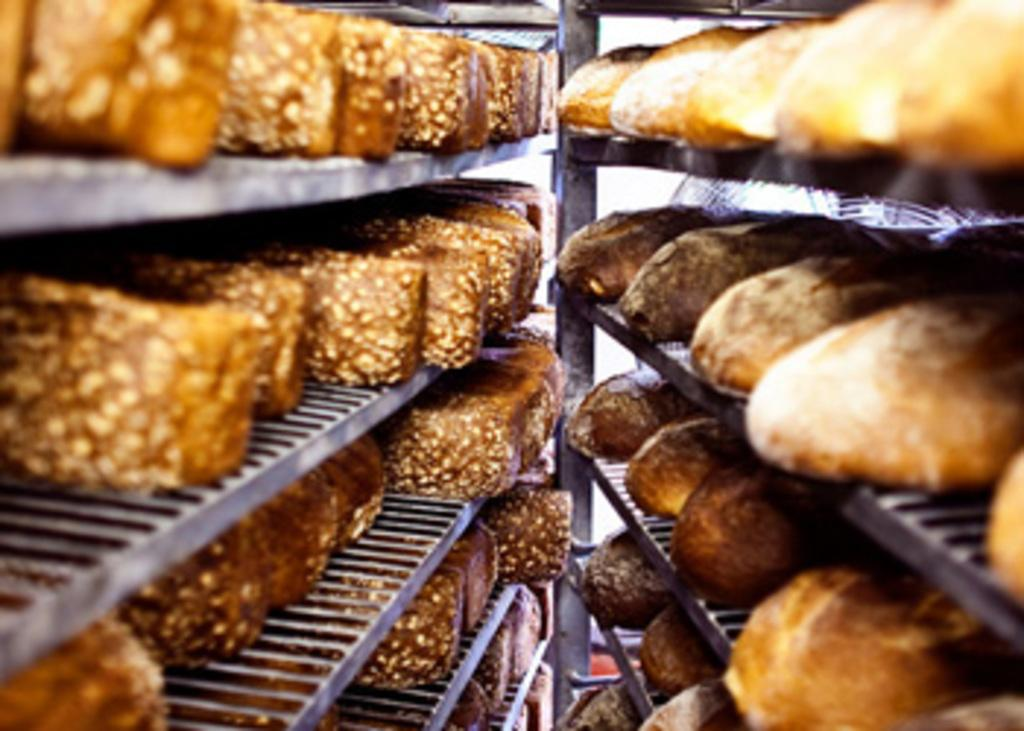What is the main subject of the image? The main subject of the image is a group of food items. How are the food items arranged in the image? The food items are in racks. What type of flowers can be seen growing among the food items in the image? There are no flowers present in the image; it only features a group of food items arranged in racks. 